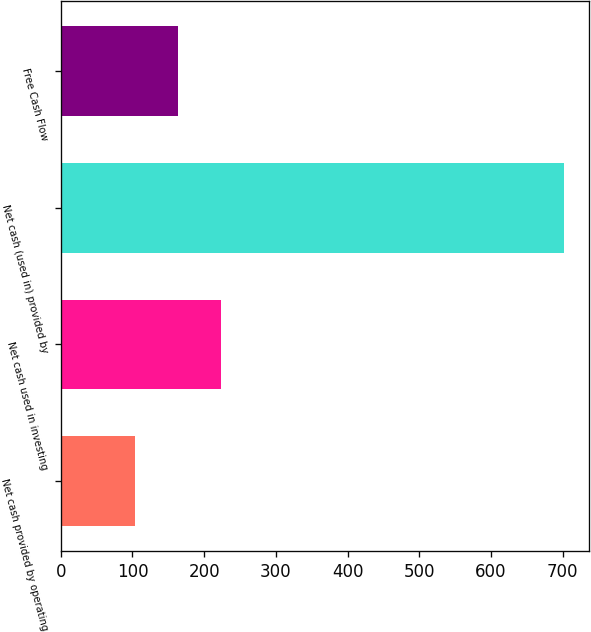Convert chart to OTSL. <chart><loc_0><loc_0><loc_500><loc_500><bar_chart><fcel>Net cash provided by operating<fcel>Net cash used in investing<fcel>Net cash (used in) provided by<fcel>Free Cash Flow<nl><fcel>103.7<fcel>223.24<fcel>701.4<fcel>163.47<nl></chart> 